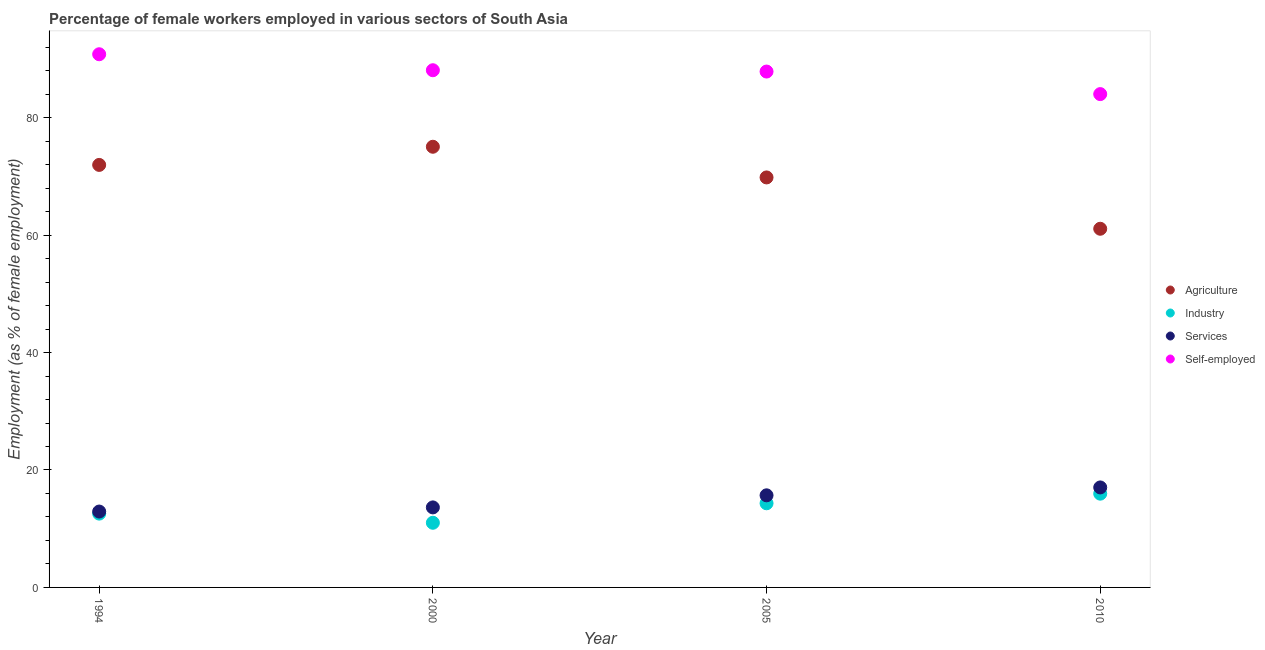How many different coloured dotlines are there?
Give a very brief answer. 4. Is the number of dotlines equal to the number of legend labels?
Your response must be concise. Yes. What is the percentage of female workers in agriculture in 2005?
Make the answer very short. 69.82. Across all years, what is the maximum percentage of self employed female workers?
Offer a terse response. 90.79. Across all years, what is the minimum percentage of self employed female workers?
Your response must be concise. 84.01. In which year was the percentage of female workers in services maximum?
Offer a very short reply. 2010. In which year was the percentage of female workers in industry minimum?
Keep it short and to the point. 2000. What is the total percentage of self employed female workers in the graph?
Offer a terse response. 350.72. What is the difference between the percentage of female workers in agriculture in 1994 and that in 2000?
Your answer should be very brief. -3.09. What is the difference between the percentage of female workers in agriculture in 1994 and the percentage of self employed female workers in 2010?
Ensure brevity in your answer.  -12.06. What is the average percentage of self employed female workers per year?
Ensure brevity in your answer.  87.68. In the year 2005, what is the difference between the percentage of self employed female workers and percentage of female workers in services?
Provide a succinct answer. 72.16. What is the ratio of the percentage of female workers in agriculture in 1994 to that in 2010?
Keep it short and to the point. 1.18. Is the percentage of female workers in industry in 2000 less than that in 2005?
Provide a short and direct response. Yes. Is the difference between the percentage of female workers in industry in 2000 and 2005 greater than the difference between the percentage of female workers in services in 2000 and 2005?
Your response must be concise. No. What is the difference between the highest and the second highest percentage of female workers in agriculture?
Give a very brief answer. 3.09. What is the difference between the highest and the lowest percentage of self employed female workers?
Keep it short and to the point. 6.79. Is the percentage of self employed female workers strictly greater than the percentage of female workers in agriculture over the years?
Your answer should be very brief. Yes. Is the percentage of female workers in services strictly less than the percentage of female workers in industry over the years?
Offer a very short reply. No. Does the graph contain any zero values?
Provide a short and direct response. No. Where does the legend appear in the graph?
Offer a very short reply. Center right. How are the legend labels stacked?
Your answer should be compact. Vertical. What is the title of the graph?
Your answer should be very brief. Percentage of female workers employed in various sectors of South Asia. Does "Public sector management" appear as one of the legend labels in the graph?
Offer a very short reply. No. What is the label or title of the X-axis?
Provide a succinct answer. Year. What is the label or title of the Y-axis?
Provide a succinct answer. Employment (as % of female employment). What is the Employment (as % of female employment) in Agriculture in 1994?
Your response must be concise. 71.95. What is the Employment (as % of female employment) of Industry in 1994?
Give a very brief answer. 12.57. What is the Employment (as % of female employment) in Services in 1994?
Give a very brief answer. 12.92. What is the Employment (as % of female employment) in Self-employed in 1994?
Your answer should be compact. 90.79. What is the Employment (as % of female employment) of Agriculture in 2000?
Offer a terse response. 75.04. What is the Employment (as % of female employment) of Industry in 2000?
Provide a succinct answer. 11.01. What is the Employment (as % of female employment) in Services in 2000?
Offer a terse response. 13.63. What is the Employment (as % of female employment) in Self-employed in 2000?
Offer a terse response. 88.07. What is the Employment (as % of female employment) of Agriculture in 2005?
Ensure brevity in your answer.  69.82. What is the Employment (as % of female employment) in Industry in 2005?
Offer a very short reply. 14.33. What is the Employment (as % of female employment) of Services in 2005?
Provide a succinct answer. 15.68. What is the Employment (as % of female employment) in Self-employed in 2005?
Provide a short and direct response. 87.85. What is the Employment (as % of female employment) of Agriculture in 2010?
Make the answer very short. 61.08. What is the Employment (as % of female employment) in Industry in 2010?
Give a very brief answer. 15.96. What is the Employment (as % of female employment) of Services in 2010?
Give a very brief answer. 17.03. What is the Employment (as % of female employment) of Self-employed in 2010?
Provide a succinct answer. 84.01. Across all years, what is the maximum Employment (as % of female employment) of Agriculture?
Make the answer very short. 75.04. Across all years, what is the maximum Employment (as % of female employment) of Industry?
Make the answer very short. 15.96. Across all years, what is the maximum Employment (as % of female employment) of Services?
Your answer should be compact. 17.03. Across all years, what is the maximum Employment (as % of female employment) of Self-employed?
Give a very brief answer. 90.79. Across all years, what is the minimum Employment (as % of female employment) of Agriculture?
Give a very brief answer. 61.08. Across all years, what is the minimum Employment (as % of female employment) in Industry?
Provide a short and direct response. 11.01. Across all years, what is the minimum Employment (as % of female employment) of Services?
Provide a succinct answer. 12.92. Across all years, what is the minimum Employment (as % of female employment) of Self-employed?
Offer a terse response. 84.01. What is the total Employment (as % of female employment) of Agriculture in the graph?
Your response must be concise. 277.89. What is the total Employment (as % of female employment) of Industry in the graph?
Your response must be concise. 53.87. What is the total Employment (as % of female employment) in Services in the graph?
Give a very brief answer. 59.26. What is the total Employment (as % of female employment) of Self-employed in the graph?
Give a very brief answer. 350.72. What is the difference between the Employment (as % of female employment) in Agriculture in 1994 and that in 2000?
Your answer should be compact. -3.09. What is the difference between the Employment (as % of female employment) of Industry in 1994 and that in 2000?
Your answer should be compact. 1.56. What is the difference between the Employment (as % of female employment) of Services in 1994 and that in 2000?
Provide a short and direct response. -0.71. What is the difference between the Employment (as % of female employment) of Self-employed in 1994 and that in 2000?
Your answer should be compact. 2.72. What is the difference between the Employment (as % of female employment) of Agriculture in 1994 and that in 2005?
Keep it short and to the point. 2.13. What is the difference between the Employment (as % of female employment) of Industry in 1994 and that in 2005?
Ensure brevity in your answer.  -1.76. What is the difference between the Employment (as % of female employment) of Services in 1994 and that in 2005?
Ensure brevity in your answer.  -2.76. What is the difference between the Employment (as % of female employment) of Self-employed in 1994 and that in 2005?
Ensure brevity in your answer.  2.95. What is the difference between the Employment (as % of female employment) in Agriculture in 1994 and that in 2010?
Provide a succinct answer. 10.87. What is the difference between the Employment (as % of female employment) in Industry in 1994 and that in 2010?
Offer a very short reply. -3.4. What is the difference between the Employment (as % of female employment) of Services in 1994 and that in 2010?
Your response must be concise. -4.11. What is the difference between the Employment (as % of female employment) in Self-employed in 1994 and that in 2010?
Offer a very short reply. 6.79. What is the difference between the Employment (as % of female employment) of Agriculture in 2000 and that in 2005?
Your answer should be compact. 5.22. What is the difference between the Employment (as % of female employment) in Industry in 2000 and that in 2005?
Ensure brevity in your answer.  -3.32. What is the difference between the Employment (as % of female employment) in Services in 2000 and that in 2005?
Your response must be concise. -2.06. What is the difference between the Employment (as % of female employment) of Self-employed in 2000 and that in 2005?
Your answer should be very brief. 0.22. What is the difference between the Employment (as % of female employment) in Agriculture in 2000 and that in 2010?
Your answer should be very brief. 13.96. What is the difference between the Employment (as % of female employment) in Industry in 2000 and that in 2010?
Provide a succinct answer. -4.95. What is the difference between the Employment (as % of female employment) in Services in 2000 and that in 2010?
Keep it short and to the point. -3.4. What is the difference between the Employment (as % of female employment) of Self-employed in 2000 and that in 2010?
Make the answer very short. 4.07. What is the difference between the Employment (as % of female employment) in Agriculture in 2005 and that in 2010?
Your response must be concise. 8.74. What is the difference between the Employment (as % of female employment) of Industry in 2005 and that in 2010?
Offer a terse response. -1.64. What is the difference between the Employment (as % of female employment) of Services in 2005 and that in 2010?
Your answer should be compact. -1.34. What is the difference between the Employment (as % of female employment) of Self-employed in 2005 and that in 2010?
Your response must be concise. 3.84. What is the difference between the Employment (as % of female employment) of Agriculture in 1994 and the Employment (as % of female employment) of Industry in 2000?
Provide a short and direct response. 60.94. What is the difference between the Employment (as % of female employment) of Agriculture in 1994 and the Employment (as % of female employment) of Services in 2000?
Ensure brevity in your answer.  58.32. What is the difference between the Employment (as % of female employment) of Agriculture in 1994 and the Employment (as % of female employment) of Self-employed in 2000?
Offer a terse response. -16.12. What is the difference between the Employment (as % of female employment) of Industry in 1994 and the Employment (as % of female employment) of Services in 2000?
Give a very brief answer. -1.06. What is the difference between the Employment (as % of female employment) of Industry in 1994 and the Employment (as % of female employment) of Self-employed in 2000?
Your answer should be very brief. -75.5. What is the difference between the Employment (as % of female employment) in Services in 1994 and the Employment (as % of female employment) in Self-employed in 2000?
Offer a terse response. -75.15. What is the difference between the Employment (as % of female employment) of Agriculture in 1994 and the Employment (as % of female employment) of Industry in 2005?
Your answer should be compact. 57.62. What is the difference between the Employment (as % of female employment) of Agriculture in 1994 and the Employment (as % of female employment) of Services in 2005?
Make the answer very short. 56.27. What is the difference between the Employment (as % of female employment) in Agriculture in 1994 and the Employment (as % of female employment) in Self-employed in 2005?
Your answer should be compact. -15.9. What is the difference between the Employment (as % of female employment) in Industry in 1994 and the Employment (as % of female employment) in Services in 2005?
Keep it short and to the point. -3.11. What is the difference between the Employment (as % of female employment) of Industry in 1994 and the Employment (as % of female employment) of Self-employed in 2005?
Keep it short and to the point. -75.28. What is the difference between the Employment (as % of female employment) of Services in 1994 and the Employment (as % of female employment) of Self-employed in 2005?
Offer a very short reply. -74.93. What is the difference between the Employment (as % of female employment) in Agriculture in 1994 and the Employment (as % of female employment) in Industry in 2010?
Your response must be concise. 55.99. What is the difference between the Employment (as % of female employment) of Agriculture in 1994 and the Employment (as % of female employment) of Services in 2010?
Your response must be concise. 54.92. What is the difference between the Employment (as % of female employment) of Agriculture in 1994 and the Employment (as % of female employment) of Self-employed in 2010?
Keep it short and to the point. -12.06. What is the difference between the Employment (as % of female employment) in Industry in 1994 and the Employment (as % of female employment) in Services in 2010?
Your answer should be very brief. -4.46. What is the difference between the Employment (as % of female employment) in Industry in 1994 and the Employment (as % of female employment) in Self-employed in 2010?
Give a very brief answer. -71.44. What is the difference between the Employment (as % of female employment) of Services in 1994 and the Employment (as % of female employment) of Self-employed in 2010?
Ensure brevity in your answer.  -71.09. What is the difference between the Employment (as % of female employment) in Agriculture in 2000 and the Employment (as % of female employment) in Industry in 2005?
Your response must be concise. 60.71. What is the difference between the Employment (as % of female employment) in Agriculture in 2000 and the Employment (as % of female employment) in Services in 2005?
Keep it short and to the point. 59.36. What is the difference between the Employment (as % of female employment) of Agriculture in 2000 and the Employment (as % of female employment) of Self-employed in 2005?
Provide a succinct answer. -12.81. What is the difference between the Employment (as % of female employment) in Industry in 2000 and the Employment (as % of female employment) in Services in 2005?
Make the answer very short. -4.67. What is the difference between the Employment (as % of female employment) in Industry in 2000 and the Employment (as % of female employment) in Self-employed in 2005?
Provide a short and direct response. -76.84. What is the difference between the Employment (as % of female employment) of Services in 2000 and the Employment (as % of female employment) of Self-employed in 2005?
Your response must be concise. -74.22. What is the difference between the Employment (as % of female employment) of Agriculture in 2000 and the Employment (as % of female employment) of Industry in 2010?
Your response must be concise. 59.08. What is the difference between the Employment (as % of female employment) of Agriculture in 2000 and the Employment (as % of female employment) of Services in 2010?
Ensure brevity in your answer.  58.01. What is the difference between the Employment (as % of female employment) of Agriculture in 2000 and the Employment (as % of female employment) of Self-employed in 2010?
Provide a succinct answer. -8.97. What is the difference between the Employment (as % of female employment) of Industry in 2000 and the Employment (as % of female employment) of Services in 2010?
Your response must be concise. -6.02. What is the difference between the Employment (as % of female employment) in Industry in 2000 and the Employment (as % of female employment) in Self-employed in 2010?
Offer a very short reply. -73. What is the difference between the Employment (as % of female employment) in Services in 2000 and the Employment (as % of female employment) in Self-employed in 2010?
Your response must be concise. -70.38. What is the difference between the Employment (as % of female employment) of Agriculture in 2005 and the Employment (as % of female employment) of Industry in 2010?
Your answer should be very brief. 53.85. What is the difference between the Employment (as % of female employment) in Agriculture in 2005 and the Employment (as % of female employment) in Services in 2010?
Ensure brevity in your answer.  52.79. What is the difference between the Employment (as % of female employment) of Agriculture in 2005 and the Employment (as % of female employment) of Self-employed in 2010?
Make the answer very short. -14.19. What is the difference between the Employment (as % of female employment) in Industry in 2005 and the Employment (as % of female employment) in Services in 2010?
Ensure brevity in your answer.  -2.7. What is the difference between the Employment (as % of female employment) of Industry in 2005 and the Employment (as % of female employment) of Self-employed in 2010?
Keep it short and to the point. -69.68. What is the difference between the Employment (as % of female employment) in Services in 2005 and the Employment (as % of female employment) in Self-employed in 2010?
Make the answer very short. -68.32. What is the average Employment (as % of female employment) of Agriculture per year?
Ensure brevity in your answer.  69.47. What is the average Employment (as % of female employment) of Industry per year?
Provide a succinct answer. 13.47. What is the average Employment (as % of female employment) in Services per year?
Offer a terse response. 14.82. What is the average Employment (as % of female employment) in Self-employed per year?
Your answer should be compact. 87.68. In the year 1994, what is the difference between the Employment (as % of female employment) in Agriculture and Employment (as % of female employment) in Industry?
Give a very brief answer. 59.38. In the year 1994, what is the difference between the Employment (as % of female employment) of Agriculture and Employment (as % of female employment) of Services?
Your answer should be very brief. 59.03. In the year 1994, what is the difference between the Employment (as % of female employment) of Agriculture and Employment (as % of female employment) of Self-employed?
Your response must be concise. -18.84. In the year 1994, what is the difference between the Employment (as % of female employment) of Industry and Employment (as % of female employment) of Services?
Keep it short and to the point. -0.35. In the year 1994, what is the difference between the Employment (as % of female employment) in Industry and Employment (as % of female employment) in Self-employed?
Provide a short and direct response. -78.23. In the year 1994, what is the difference between the Employment (as % of female employment) in Services and Employment (as % of female employment) in Self-employed?
Provide a succinct answer. -77.87. In the year 2000, what is the difference between the Employment (as % of female employment) in Agriculture and Employment (as % of female employment) in Industry?
Give a very brief answer. 64.03. In the year 2000, what is the difference between the Employment (as % of female employment) of Agriculture and Employment (as % of female employment) of Services?
Give a very brief answer. 61.42. In the year 2000, what is the difference between the Employment (as % of female employment) of Agriculture and Employment (as % of female employment) of Self-employed?
Your answer should be very brief. -13.03. In the year 2000, what is the difference between the Employment (as % of female employment) in Industry and Employment (as % of female employment) in Services?
Make the answer very short. -2.62. In the year 2000, what is the difference between the Employment (as % of female employment) of Industry and Employment (as % of female employment) of Self-employed?
Give a very brief answer. -77.06. In the year 2000, what is the difference between the Employment (as % of female employment) of Services and Employment (as % of female employment) of Self-employed?
Provide a succinct answer. -74.45. In the year 2005, what is the difference between the Employment (as % of female employment) of Agriculture and Employment (as % of female employment) of Industry?
Your answer should be very brief. 55.49. In the year 2005, what is the difference between the Employment (as % of female employment) of Agriculture and Employment (as % of female employment) of Services?
Offer a terse response. 54.13. In the year 2005, what is the difference between the Employment (as % of female employment) of Agriculture and Employment (as % of female employment) of Self-employed?
Offer a very short reply. -18.03. In the year 2005, what is the difference between the Employment (as % of female employment) of Industry and Employment (as % of female employment) of Services?
Your answer should be very brief. -1.36. In the year 2005, what is the difference between the Employment (as % of female employment) of Industry and Employment (as % of female employment) of Self-employed?
Provide a succinct answer. -73.52. In the year 2005, what is the difference between the Employment (as % of female employment) of Services and Employment (as % of female employment) of Self-employed?
Ensure brevity in your answer.  -72.16. In the year 2010, what is the difference between the Employment (as % of female employment) of Agriculture and Employment (as % of female employment) of Industry?
Your response must be concise. 45.11. In the year 2010, what is the difference between the Employment (as % of female employment) of Agriculture and Employment (as % of female employment) of Services?
Provide a succinct answer. 44.05. In the year 2010, what is the difference between the Employment (as % of female employment) of Agriculture and Employment (as % of female employment) of Self-employed?
Make the answer very short. -22.93. In the year 2010, what is the difference between the Employment (as % of female employment) in Industry and Employment (as % of female employment) in Services?
Provide a short and direct response. -1.06. In the year 2010, what is the difference between the Employment (as % of female employment) in Industry and Employment (as % of female employment) in Self-employed?
Provide a succinct answer. -68.04. In the year 2010, what is the difference between the Employment (as % of female employment) of Services and Employment (as % of female employment) of Self-employed?
Offer a terse response. -66.98. What is the ratio of the Employment (as % of female employment) of Agriculture in 1994 to that in 2000?
Provide a short and direct response. 0.96. What is the ratio of the Employment (as % of female employment) of Industry in 1994 to that in 2000?
Give a very brief answer. 1.14. What is the ratio of the Employment (as % of female employment) in Services in 1994 to that in 2000?
Offer a very short reply. 0.95. What is the ratio of the Employment (as % of female employment) of Self-employed in 1994 to that in 2000?
Your answer should be compact. 1.03. What is the ratio of the Employment (as % of female employment) of Agriculture in 1994 to that in 2005?
Make the answer very short. 1.03. What is the ratio of the Employment (as % of female employment) of Industry in 1994 to that in 2005?
Make the answer very short. 0.88. What is the ratio of the Employment (as % of female employment) in Services in 1994 to that in 2005?
Your answer should be compact. 0.82. What is the ratio of the Employment (as % of female employment) in Self-employed in 1994 to that in 2005?
Offer a very short reply. 1.03. What is the ratio of the Employment (as % of female employment) in Agriculture in 1994 to that in 2010?
Provide a succinct answer. 1.18. What is the ratio of the Employment (as % of female employment) in Industry in 1994 to that in 2010?
Keep it short and to the point. 0.79. What is the ratio of the Employment (as % of female employment) of Services in 1994 to that in 2010?
Make the answer very short. 0.76. What is the ratio of the Employment (as % of female employment) of Self-employed in 1994 to that in 2010?
Make the answer very short. 1.08. What is the ratio of the Employment (as % of female employment) in Agriculture in 2000 to that in 2005?
Ensure brevity in your answer.  1.07. What is the ratio of the Employment (as % of female employment) in Industry in 2000 to that in 2005?
Your answer should be very brief. 0.77. What is the ratio of the Employment (as % of female employment) of Services in 2000 to that in 2005?
Offer a very short reply. 0.87. What is the ratio of the Employment (as % of female employment) in Self-employed in 2000 to that in 2005?
Make the answer very short. 1. What is the ratio of the Employment (as % of female employment) of Agriculture in 2000 to that in 2010?
Your response must be concise. 1.23. What is the ratio of the Employment (as % of female employment) in Industry in 2000 to that in 2010?
Keep it short and to the point. 0.69. What is the ratio of the Employment (as % of female employment) in Services in 2000 to that in 2010?
Your answer should be compact. 0.8. What is the ratio of the Employment (as % of female employment) of Self-employed in 2000 to that in 2010?
Provide a short and direct response. 1.05. What is the ratio of the Employment (as % of female employment) in Agriculture in 2005 to that in 2010?
Provide a succinct answer. 1.14. What is the ratio of the Employment (as % of female employment) of Industry in 2005 to that in 2010?
Your response must be concise. 0.9. What is the ratio of the Employment (as % of female employment) of Services in 2005 to that in 2010?
Offer a terse response. 0.92. What is the ratio of the Employment (as % of female employment) in Self-employed in 2005 to that in 2010?
Offer a terse response. 1.05. What is the difference between the highest and the second highest Employment (as % of female employment) of Agriculture?
Ensure brevity in your answer.  3.09. What is the difference between the highest and the second highest Employment (as % of female employment) of Industry?
Ensure brevity in your answer.  1.64. What is the difference between the highest and the second highest Employment (as % of female employment) in Services?
Offer a very short reply. 1.34. What is the difference between the highest and the second highest Employment (as % of female employment) of Self-employed?
Your response must be concise. 2.72. What is the difference between the highest and the lowest Employment (as % of female employment) in Agriculture?
Provide a short and direct response. 13.96. What is the difference between the highest and the lowest Employment (as % of female employment) in Industry?
Offer a terse response. 4.95. What is the difference between the highest and the lowest Employment (as % of female employment) of Services?
Give a very brief answer. 4.11. What is the difference between the highest and the lowest Employment (as % of female employment) of Self-employed?
Provide a short and direct response. 6.79. 